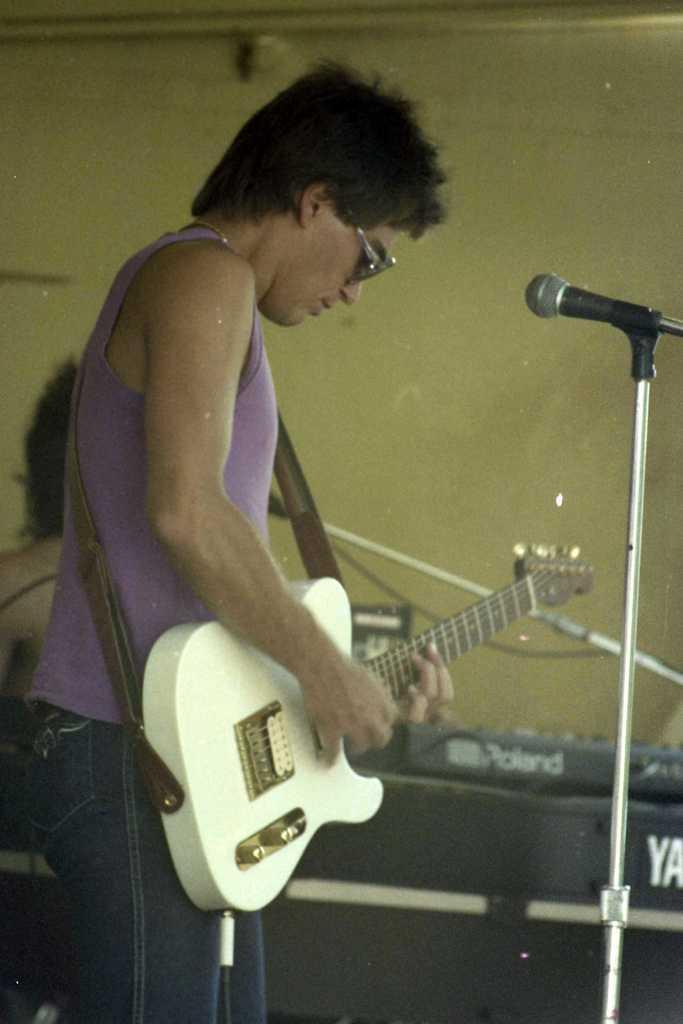Please provide a concise description of this image. Here, the man in purple t-shirt is holding guitar in his hands and playing it. He is even wearing goggles. In front of him, we see microphone. Behind him, we see a person playing musical instrument and behind these people, we see a yellow wall. 